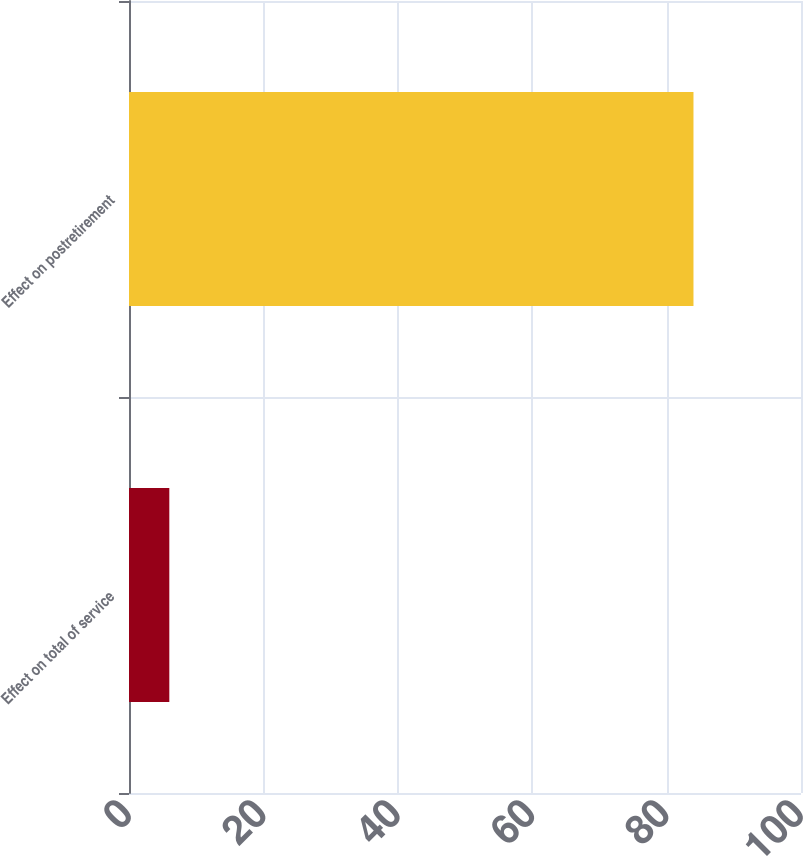<chart> <loc_0><loc_0><loc_500><loc_500><bar_chart><fcel>Effect on total of service<fcel>Effect on postretirement<nl><fcel>6<fcel>84<nl></chart> 